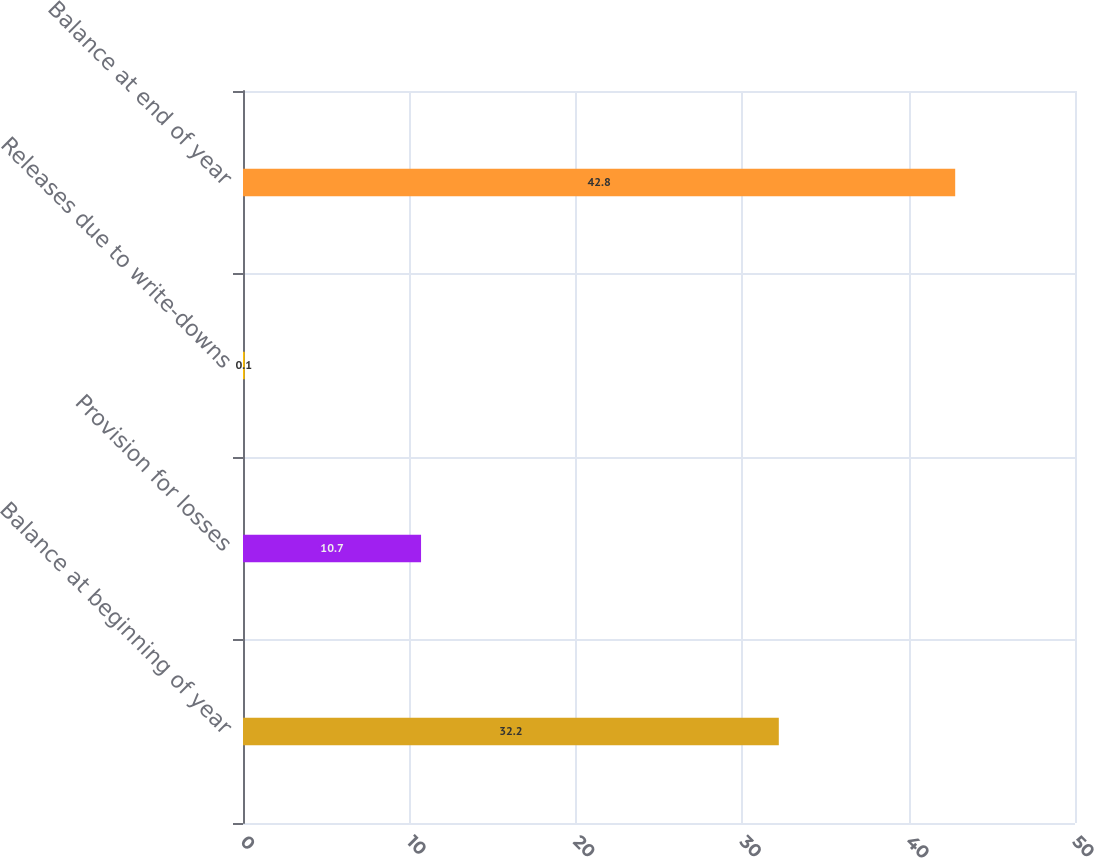Convert chart. <chart><loc_0><loc_0><loc_500><loc_500><bar_chart><fcel>Balance at beginning of year<fcel>Provision for losses<fcel>Releases due to write-downs<fcel>Balance at end of year<nl><fcel>32.2<fcel>10.7<fcel>0.1<fcel>42.8<nl></chart> 